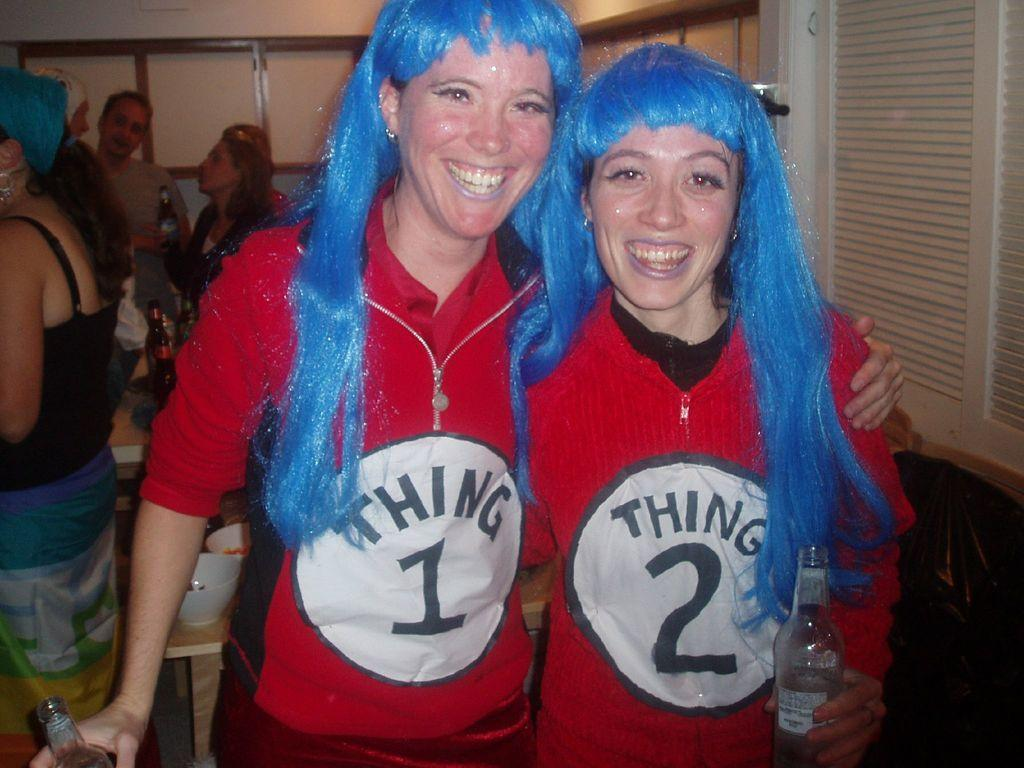<image>
Render a clear and concise summary of the photo. Two women dressed up as Thing 1 and Thing 2. 